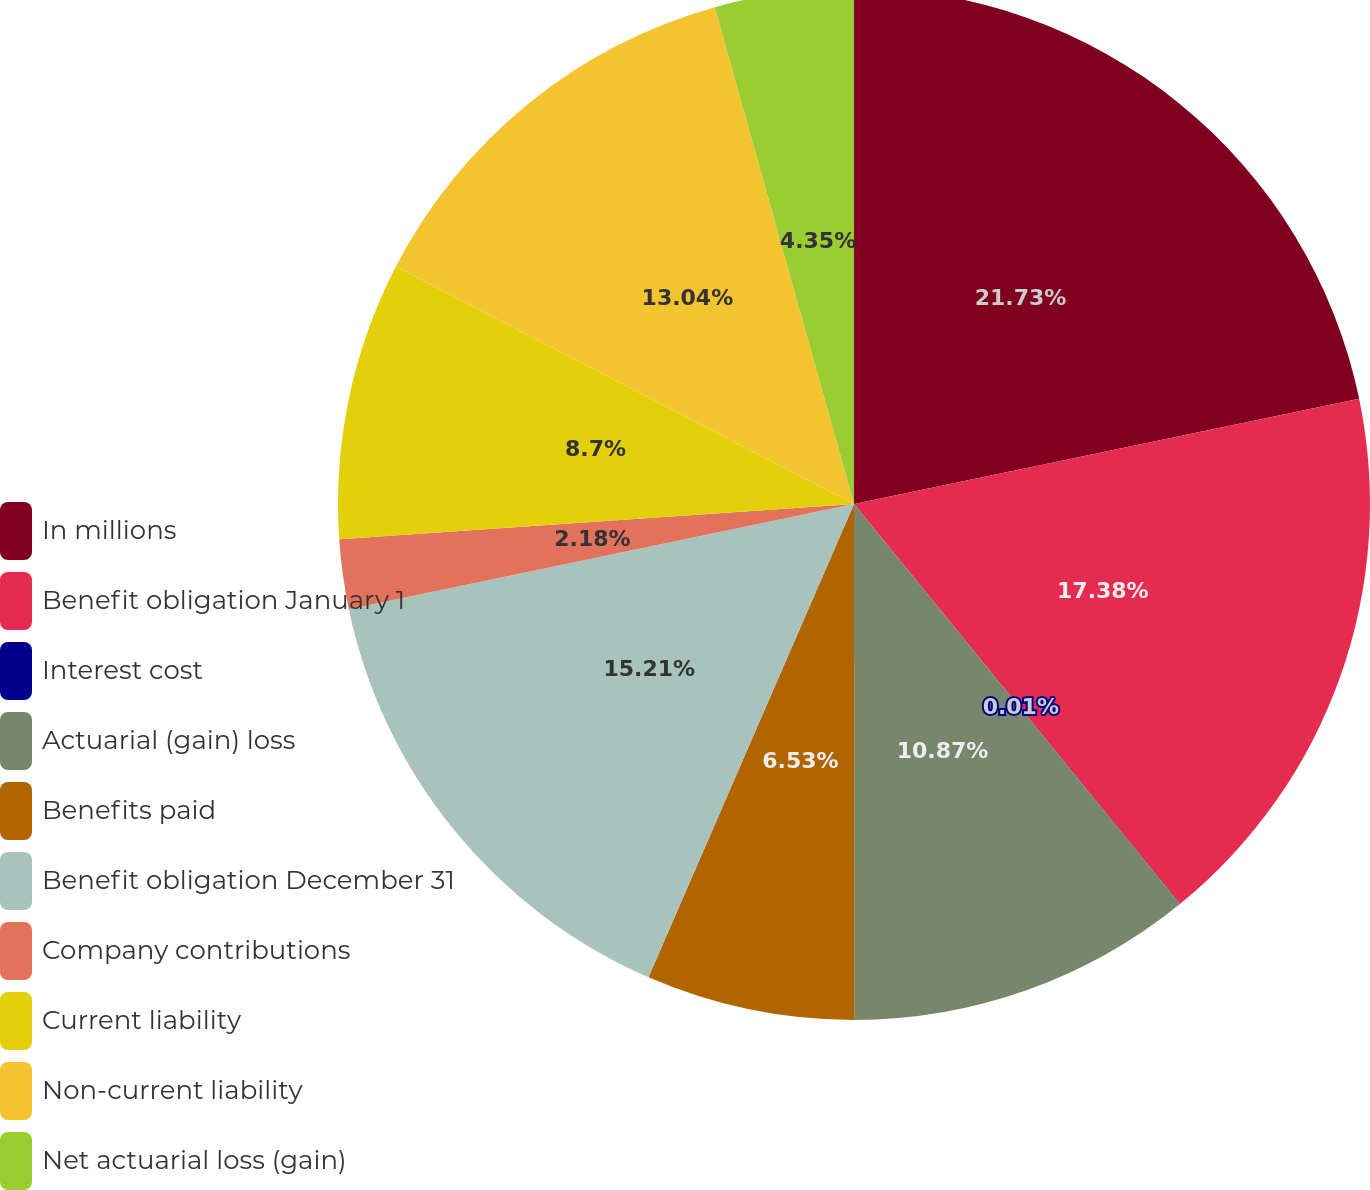Convert chart to OTSL. <chart><loc_0><loc_0><loc_500><loc_500><pie_chart><fcel>In millions<fcel>Benefit obligation January 1<fcel>Interest cost<fcel>Actuarial (gain) loss<fcel>Benefits paid<fcel>Benefit obligation December 31<fcel>Company contributions<fcel>Current liability<fcel>Non-current liability<fcel>Net actuarial loss (gain)<nl><fcel>21.73%<fcel>17.38%<fcel>0.01%<fcel>10.87%<fcel>6.53%<fcel>15.21%<fcel>2.18%<fcel>8.7%<fcel>13.04%<fcel>4.35%<nl></chart> 